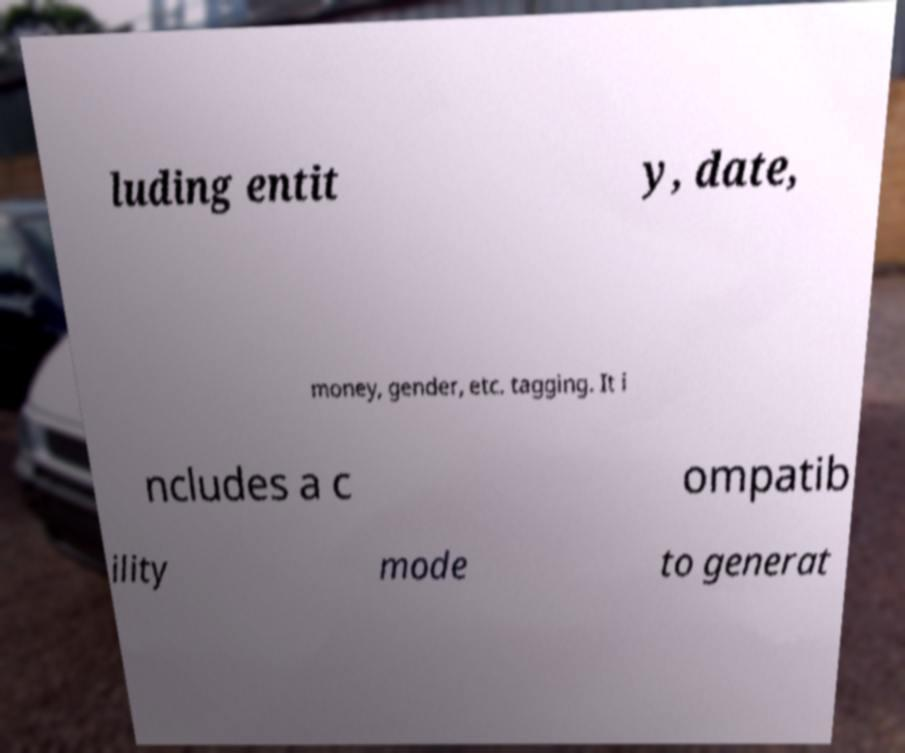Could you assist in decoding the text presented in this image and type it out clearly? luding entit y, date, money, gender, etc. tagging. It i ncludes a c ompatib ility mode to generat 